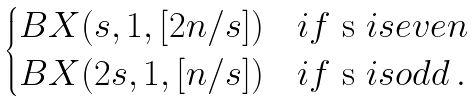<formula> <loc_0><loc_0><loc_500><loc_500>\begin{cases} B X ( s , 1 , [ 2 n / s ] ) & i f $ s $ i s e v e n \\ B X ( 2 s , 1 , [ n / s ] ) & i f $ s $ i s o d d \, . \end{cases}</formula> 